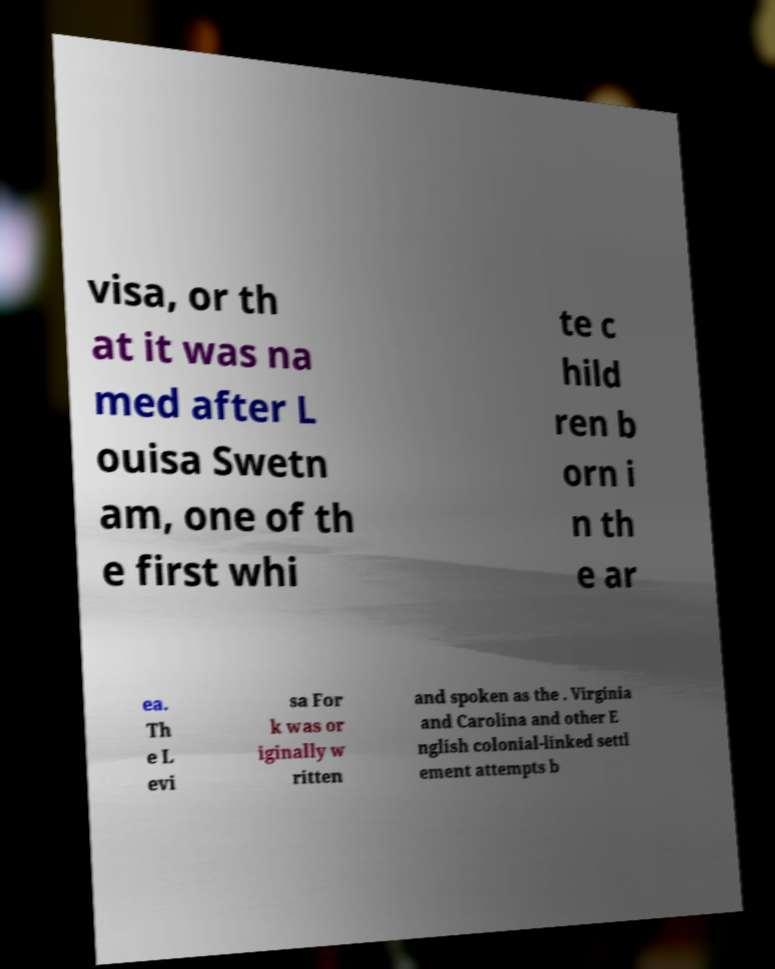For documentation purposes, I need the text within this image transcribed. Could you provide that? visa, or th at it was na med after L ouisa Swetn am, one of th e first whi te c hild ren b orn i n th e ar ea. Th e L evi sa For k was or iginally w ritten and spoken as the . Virginia and Carolina and other E nglish colonial-linked settl ement attempts b 